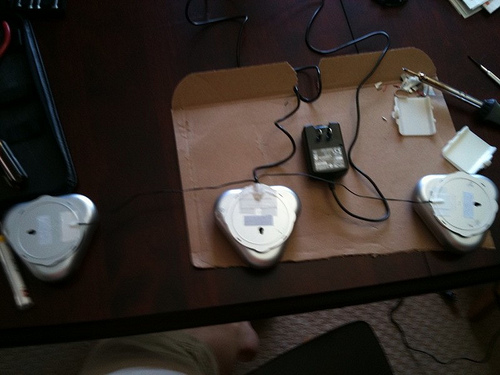<image>
Is there a charger on the table? Yes. Looking at the image, I can see the charger is positioned on top of the table, with the table providing support. 